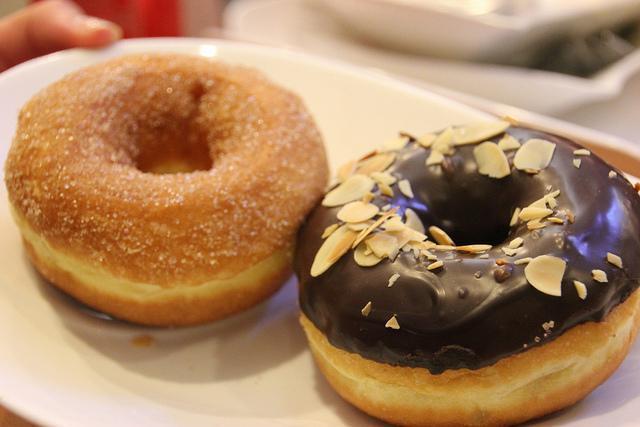How many donuts are visible?
Give a very brief answer. 2. 